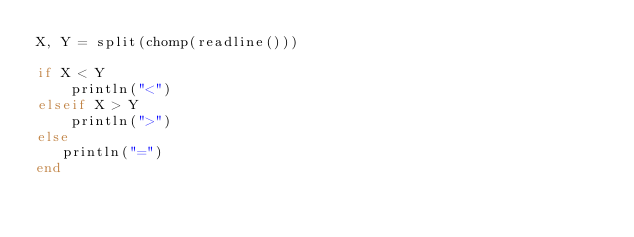<code> <loc_0><loc_0><loc_500><loc_500><_Julia_>X, Y = split(chomp(readline()))
  
if X < Y
    println("<")
elseif X > Y
    println(">")
else
   println("=")
end    </code> 